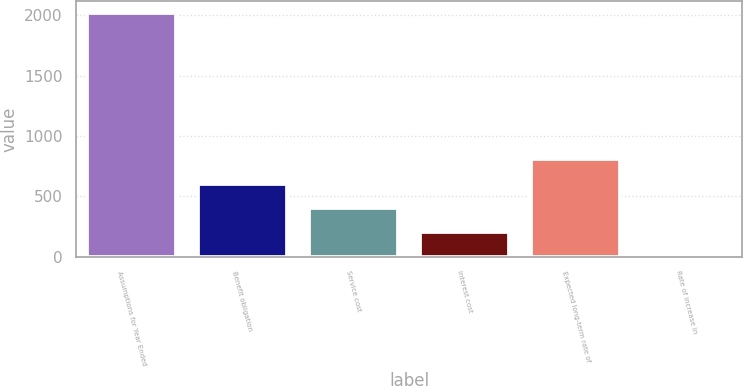<chart> <loc_0><loc_0><loc_500><loc_500><bar_chart><fcel>Assumptions for Year Ended<fcel>Benefit obligation<fcel>Service cost<fcel>Interest cost<fcel>Expected long-term rate of<fcel>Rate of increase in<nl><fcel>2016<fcel>607.17<fcel>405.91<fcel>204.65<fcel>808.43<fcel>3.39<nl></chart> 